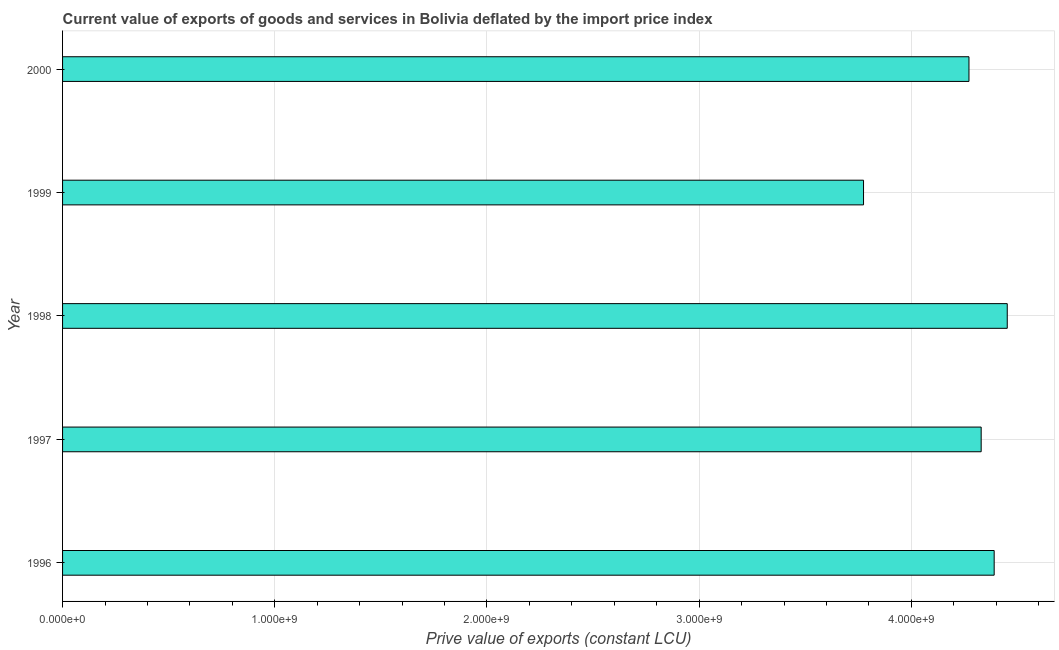Does the graph contain any zero values?
Your response must be concise. No. What is the title of the graph?
Make the answer very short. Current value of exports of goods and services in Bolivia deflated by the import price index. What is the label or title of the X-axis?
Provide a short and direct response. Prive value of exports (constant LCU). What is the price value of exports in 2000?
Provide a short and direct response. 4.27e+09. Across all years, what is the maximum price value of exports?
Your answer should be very brief. 4.45e+09. Across all years, what is the minimum price value of exports?
Your answer should be very brief. 3.77e+09. What is the sum of the price value of exports?
Your response must be concise. 2.12e+1. What is the difference between the price value of exports in 1996 and 1999?
Give a very brief answer. 6.16e+08. What is the average price value of exports per year?
Your answer should be compact. 4.24e+09. What is the median price value of exports?
Your response must be concise. 4.33e+09. Do a majority of the years between 1999 and 1997 (inclusive) have price value of exports greater than 1600000000 LCU?
Offer a terse response. Yes. What is the ratio of the price value of exports in 1998 to that in 2000?
Keep it short and to the point. 1.04. What is the difference between the highest and the second highest price value of exports?
Your answer should be compact. 6.17e+07. What is the difference between the highest and the lowest price value of exports?
Make the answer very short. 6.77e+08. How many bars are there?
Ensure brevity in your answer.  5. What is the difference between two consecutive major ticks on the X-axis?
Your response must be concise. 1.00e+09. What is the Prive value of exports (constant LCU) of 1996?
Ensure brevity in your answer.  4.39e+09. What is the Prive value of exports (constant LCU) of 1997?
Offer a very short reply. 4.33e+09. What is the Prive value of exports (constant LCU) in 1998?
Offer a terse response. 4.45e+09. What is the Prive value of exports (constant LCU) in 1999?
Offer a very short reply. 3.77e+09. What is the Prive value of exports (constant LCU) in 2000?
Keep it short and to the point. 4.27e+09. What is the difference between the Prive value of exports (constant LCU) in 1996 and 1997?
Your answer should be compact. 6.12e+07. What is the difference between the Prive value of exports (constant LCU) in 1996 and 1998?
Provide a succinct answer. -6.17e+07. What is the difference between the Prive value of exports (constant LCU) in 1996 and 1999?
Make the answer very short. 6.16e+08. What is the difference between the Prive value of exports (constant LCU) in 1996 and 2000?
Make the answer very short. 1.19e+08. What is the difference between the Prive value of exports (constant LCU) in 1997 and 1998?
Provide a short and direct response. -1.23e+08. What is the difference between the Prive value of exports (constant LCU) in 1997 and 1999?
Offer a terse response. 5.54e+08. What is the difference between the Prive value of exports (constant LCU) in 1997 and 2000?
Your response must be concise. 5.75e+07. What is the difference between the Prive value of exports (constant LCU) in 1998 and 1999?
Offer a terse response. 6.77e+08. What is the difference between the Prive value of exports (constant LCU) in 1998 and 2000?
Your answer should be compact. 1.80e+08. What is the difference between the Prive value of exports (constant LCU) in 1999 and 2000?
Provide a succinct answer. -4.97e+08. What is the ratio of the Prive value of exports (constant LCU) in 1996 to that in 1998?
Keep it short and to the point. 0.99. What is the ratio of the Prive value of exports (constant LCU) in 1996 to that in 1999?
Offer a terse response. 1.16. What is the ratio of the Prive value of exports (constant LCU) in 1996 to that in 2000?
Give a very brief answer. 1.03. What is the ratio of the Prive value of exports (constant LCU) in 1997 to that in 1998?
Keep it short and to the point. 0.97. What is the ratio of the Prive value of exports (constant LCU) in 1997 to that in 1999?
Your answer should be very brief. 1.15. What is the ratio of the Prive value of exports (constant LCU) in 1998 to that in 1999?
Your response must be concise. 1.18. What is the ratio of the Prive value of exports (constant LCU) in 1998 to that in 2000?
Give a very brief answer. 1.04. What is the ratio of the Prive value of exports (constant LCU) in 1999 to that in 2000?
Ensure brevity in your answer.  0.88. 